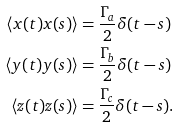Convert formula to latex. <formula><loc_0><loc_0><loc_500><loc_500>\langle x ( t ) x ( s ) \rangle & = \frac { \Gamma _ { a } } { 2 } \delta ( t - s ) \\ \langle y ( t ) y ( s ) \rangle & = \frac { \Gamma _ { b } } { 2 } \delta ( t - s ) \\ \langle z ( t ) z ( s ) \rangle & = \frac { \Gamma _ { c } } { 2 } \delta ( t - s ) .</formula> 